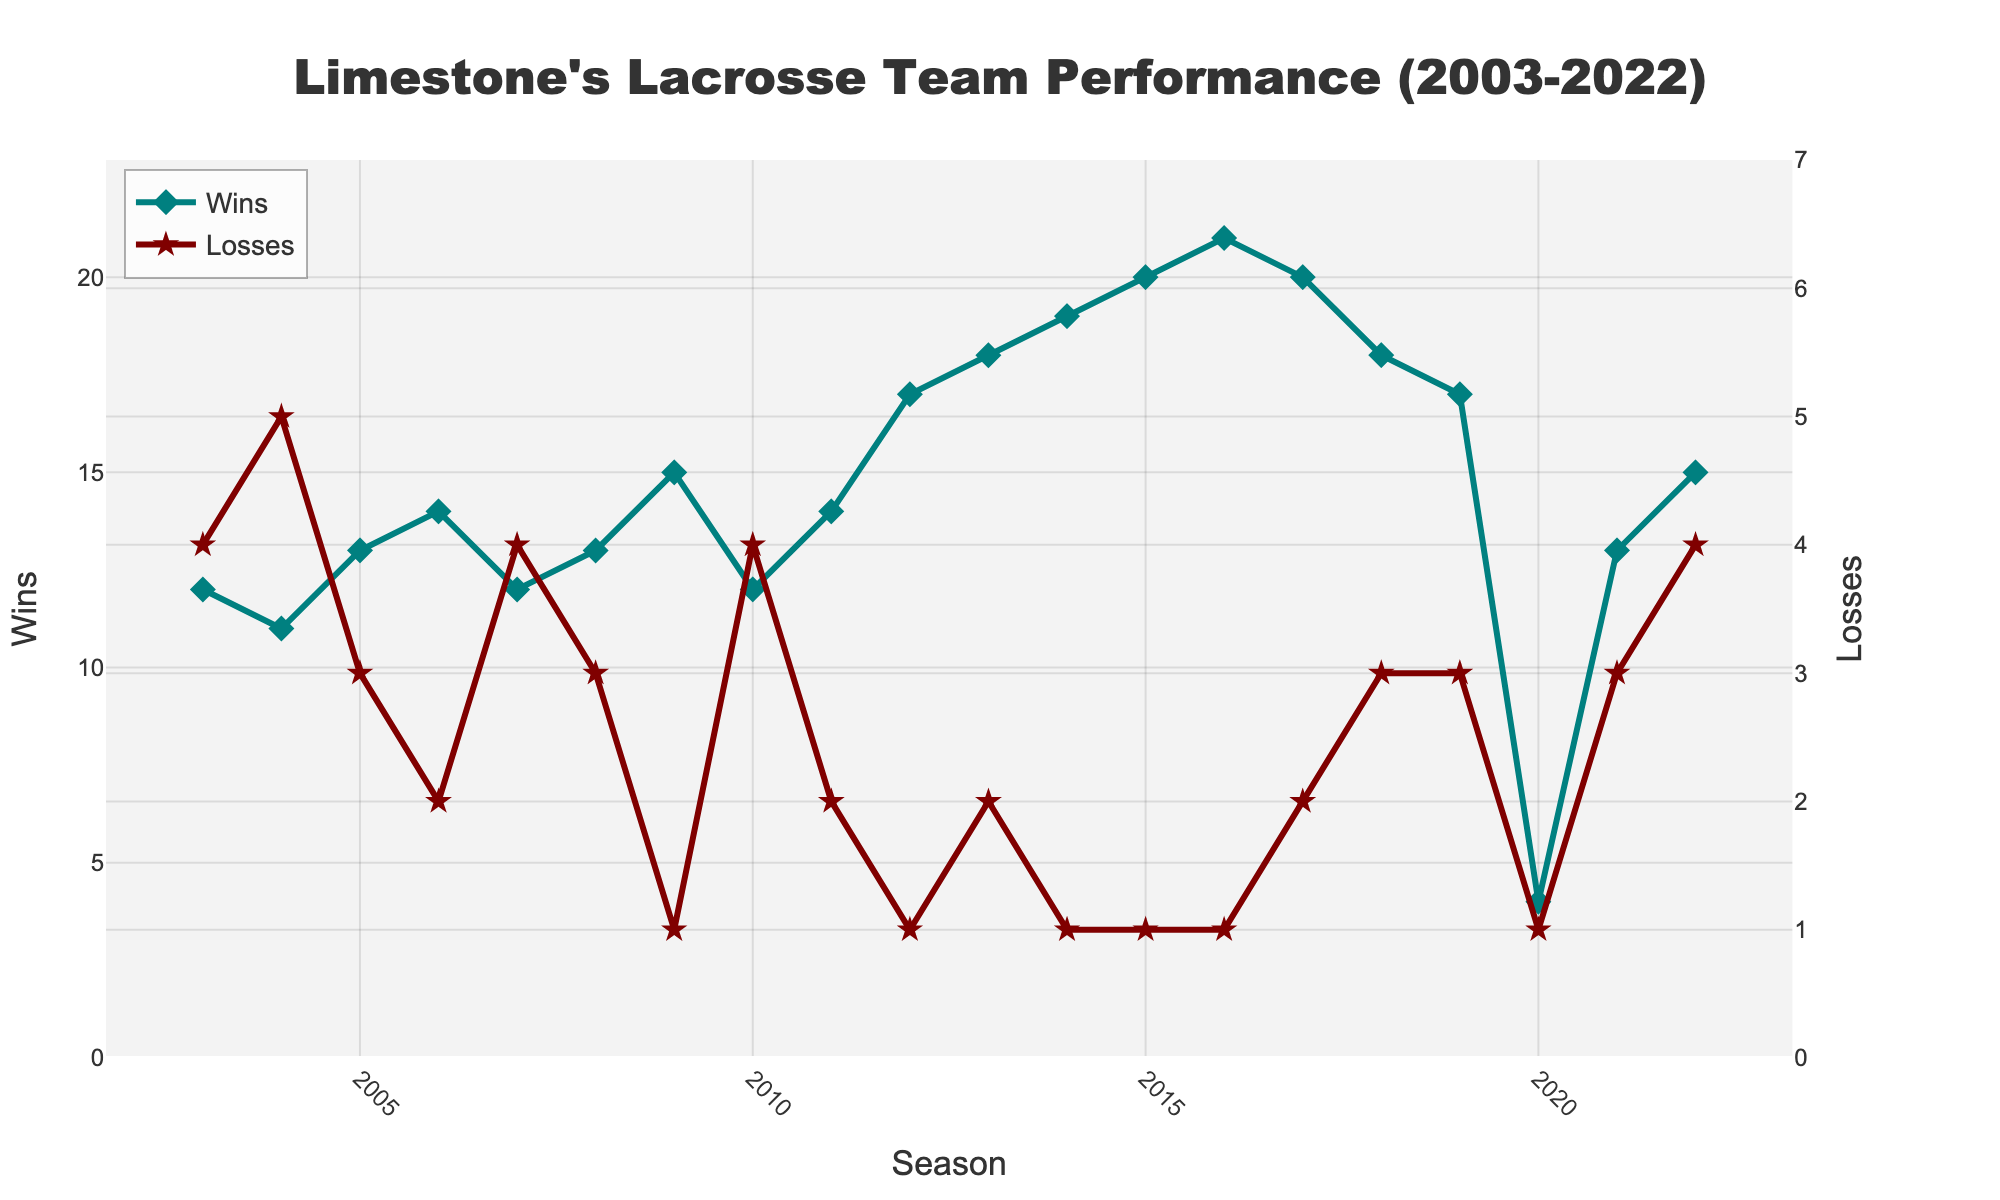What was Limestone's best season in terms of wins? Looking at the figure, which plots Wins over the seasons, the highest point on the Wins line will indicate the best season. The highest number of wins is 21, which occurred in 2016.
Answer: 2016 How did the team's performance change between 2014 and 2015? From the figure, examine both Wins and Losses lines between these two seasons. Wins increased from 19 to 20 and Losses remained the same, at 1.
Answer: Wins increased, Losses remained the same Compare Limestone's wins in 2020 to any other season. The line for Wins drops significantly in 2020 to 4 wins, which is significantly lower compared to most other seasons where wins range from 11 to 21.
Answer: 2020 had significantly fewer wins What is the average number of wins over the 20 seasons? Sum the wins from all the seasons and divide by the number of seasons (20). Total wins = 287, so the average is 287/20 = 14.35.
Answer: 14.35 During which season did Limestone have its fewest losses? The figure shows that the lowest point on the Losses line is 1 loss. This happened in multiple seasons: 2009, 2012, 2014, 2015, and 2016.
Answer: 2009, 2012, 2014, 2015, 2016 Which season had the greatest difference between wins and losses? Calculate the difference between Wins and Losses for each season. The greatest difference is in 2016, where Wins (21) - Losses (1) = 20.
Answer: 2016 Which season had more losses: 2018 or 2019? Compare the heights of the Losses line in 2018 and 2019. Losses in 2018 are 3 and in 2019 are also 3, so they are equal.
Answer: They are equal What trend can you observe in the overall win-loss record around the year 2013? Look at the segments around 2013 on both Wins and Losses lines. There is a notable increase in wins starting from 2012 peaking in 2016 and a consistent low in losses starting from 2012.
Answer: Increasing wins and low losses What is the median number of losses over the 20 seasons? List the losses in ascending order and find the middle value. Ordered losses: 1, 1, 1, 1, 1, 1, 2, 2, 2, 3, 3, 3, 3, 3, 3, 4, 4, 4, 4, 5. Median is between the 10th and 11th value, both are 3.
Answer: 3 